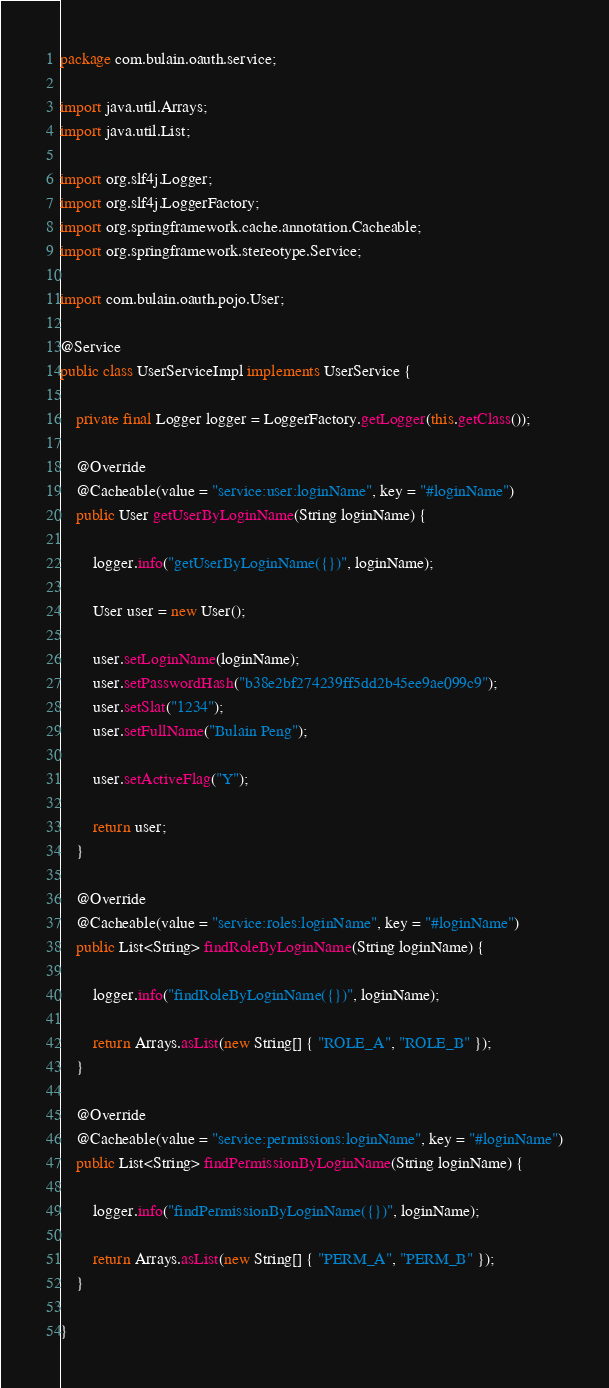<code> <loc_0><loc_0><loc_500><loc_500><_Java_>package com.bulain.oauth.service;

import java.util.Arrays;
import java.util.List;

import org.slf4j.Logger;
import org.slf4j.LoggerFactory;
import org.springframework.cache.annotation.Cacheable;
import org.springframework.stereotype.Service;

import com.bulain.oauth.pojo.User;

@Service
public class UserServiceImpl implements UserService {

	private final Logger logger = LoggerFactory.getLogger(this.getClass());

	@Override
	@Cacheable(value = "service:user:loginName", key = "#loginName")
	public User getUserByLoginName(String loginName) {

		logger.info("getUserByLoginName({})", loginName);

		User user = new User();

		user.setLoginName(loginName);
		user.setPasswordHash("b38e2bf274239ff5dd2b45ee9ae099c9");
		user.setSlat("1234");
		user.setFullName("Bulain Peng");

		user.setActiveFlag("Y");

		return user;
	}

	@Override
	@Cacheable(value = "service:roles:loginName", key = "#loginName")
	public List<String> findRoleByLoginName(String loginName) {

		logger.info("findRoleByLoginName({})", loginName);

		return Arrays.asList(new String[] { "ROLE_A", "ROLE_B" });
	}

	@Override
	@Cacheable(value = "service:permissions:loginName", key = "#loginName")
	public List<String> findPermissionByLoginName(String loginName) {

		logger.info("findPermissionByLoginName({})", loginName);

		return Arrays.asList(new String[] { "PERM_A", "PERM_B" });
	}

}
</code> 